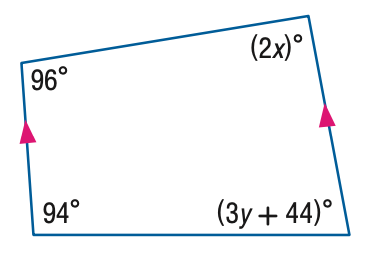Question: Find the value of the variable y in the figure.
Choices:
A. 14
B. 16.7
C. 42
D. 86
Answer with the letter. Answer: A 